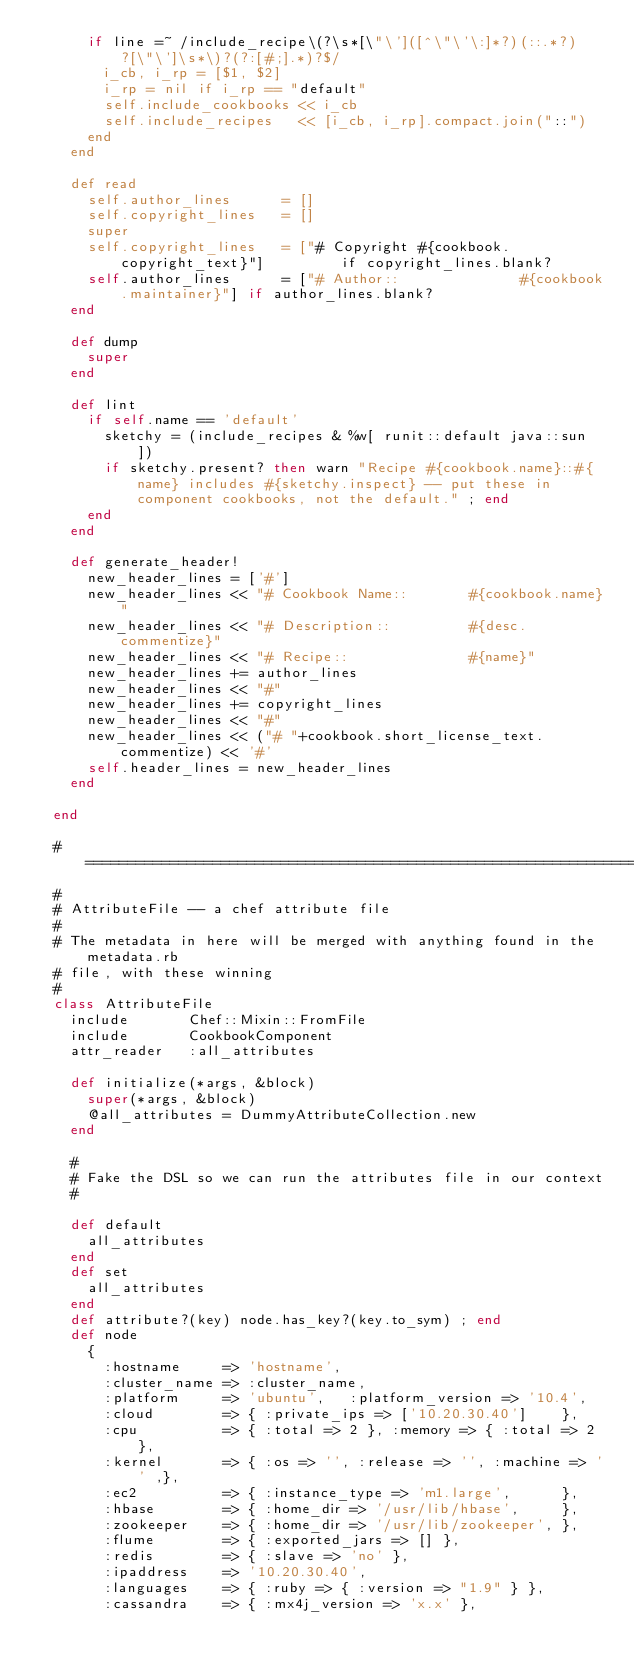<code> <loc_0><loc_0><loc_500><loc_500><_Ruby_>      if line =~ /include_recipe\(?\s*[\"\']([^\"\'\:]*?)(::.*?)?[\"\']\s*\)?(?:[#;].*)?$/
        i_cb, i_rp = [$1, $2]
        i_rp = nil if i_rp == "default"
        self.include_cookbooks << i_cb
        self.include_recipes   << [i_cb, i_rp].compact.join("::")
      end
    end

    def read
      self.author_lines      = []
      self.copyright_lines   = []
      super
      self.copyright_lines   = ["# Copyright #{cookbook.copyright_text}"]         if copyright_lines.blank?
      self.author_lines      = ["# Author::              #{cookbook.maintainer}"] if author_lines.blank?
    end

    def dump
      super
    end

    def lint
      if self.name == 'default'
        sketchy = (include_recipes & %w[ runit::default java::sun ])
        if sketchy.present? then warn "Recipe #{cookbook.name}::#{name} includes #{sketchy.inspect} -- put these in component cookbooks, not the default." ; end
      end
    end

    def generate_header!
      new_header_lines = ['#']
      new_header_lines << "# Cookbook Name::       #{cookbook.name}"
      new_header_lines << "# Description::         #{desc.commentize}"
      new_header_lines << "# Recipe::              #{name}"
      new_header_lines += author_lines
      new_header_lines << "#"
      new_header_lines += copyright_lines
      new_header_lines << "#"
      new_header_lines << ("# "+cookbook.short_license_text.commentize) << '#'
      self.header_lines = new_header_lines
    end

  end

  # ===========================================================================
  #
  # AttributeFile -- a chef attribute file
  #
  # The metadata in here will be merged with anything found in the metadata.rb
  # file, with these winning
  #
  class AttributeFile
    include       Chef::Mixin::FromFile
    include       CookbookComponent
    attr_reader   :all_attributes

    def initialize(*args, &block)
      super(*args, &block)
      @all_attributes = DummyAttributeCollection.new
    end

    #
    # Fake the DSL so we can run the attributes file in our context
    #

    def default
      all_attributes
    end
    def set
      all_attributes
    end
    def attribute?(key) node.has_key?(key.to_sym) ; end
    def node
      {
        :hostname     => 'hostname',
        :cluster_name => :cluster_name,
        :platform     => 'ubuntu',   :platform_version => '10.4',
        :cloud        => { :private_ips => ['10.20.30.40']    },
        :cpu          => { :total => 2 }, :memory => { :total => 2 },
        :kernel       => { :os => '', :release => '', :machine => '' ,},
        :ec2          => { :instance_type => 'm1.large',      },
        :hbase        => { :home_dir => '/usr/lib/hbase',     },
        :zookeeper    => { :home_dir => '/usr/lib/zookeeper', },
        :flume        => { :exported_jars => [] },
        :redis        => { :slave => 'no' },
        :ipaddress    => '10.20.30.40',
        :languages    => { :ruby => { :version => "1.9" } },
        :cassandra    => { :mx4j_version => 'x.x' },</code> 